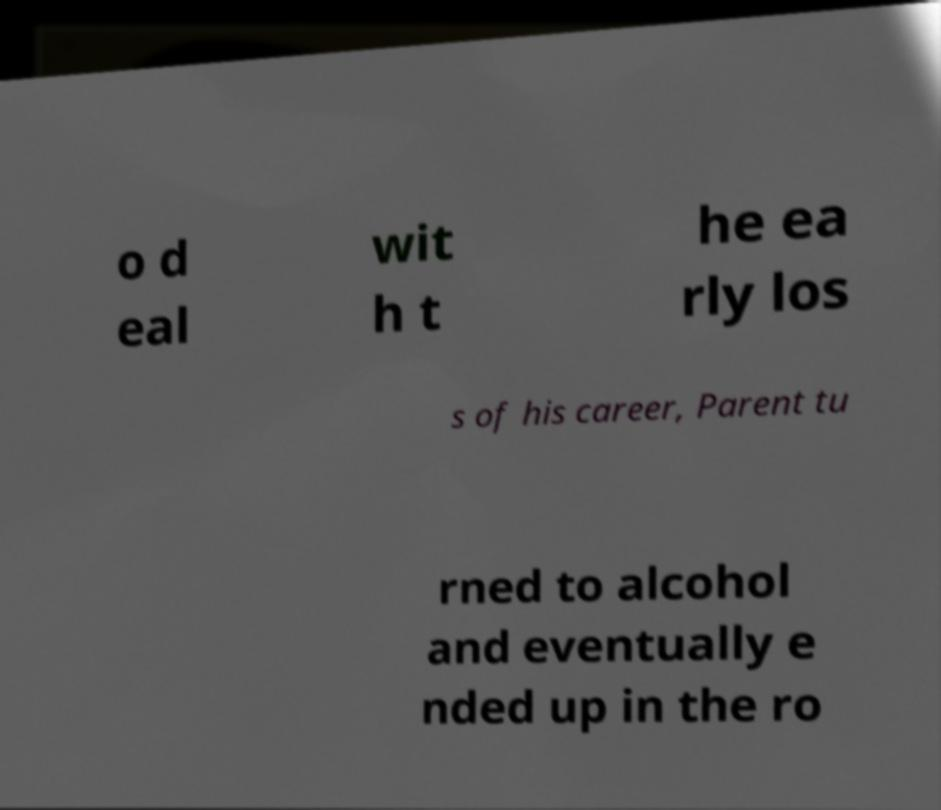What messages or text are displayed in this image? I need them in a readable, typed format. o d eal wit h t he ea rly los s of his career, Parent tu rned to alcohol and eventually e nded up in the ro 